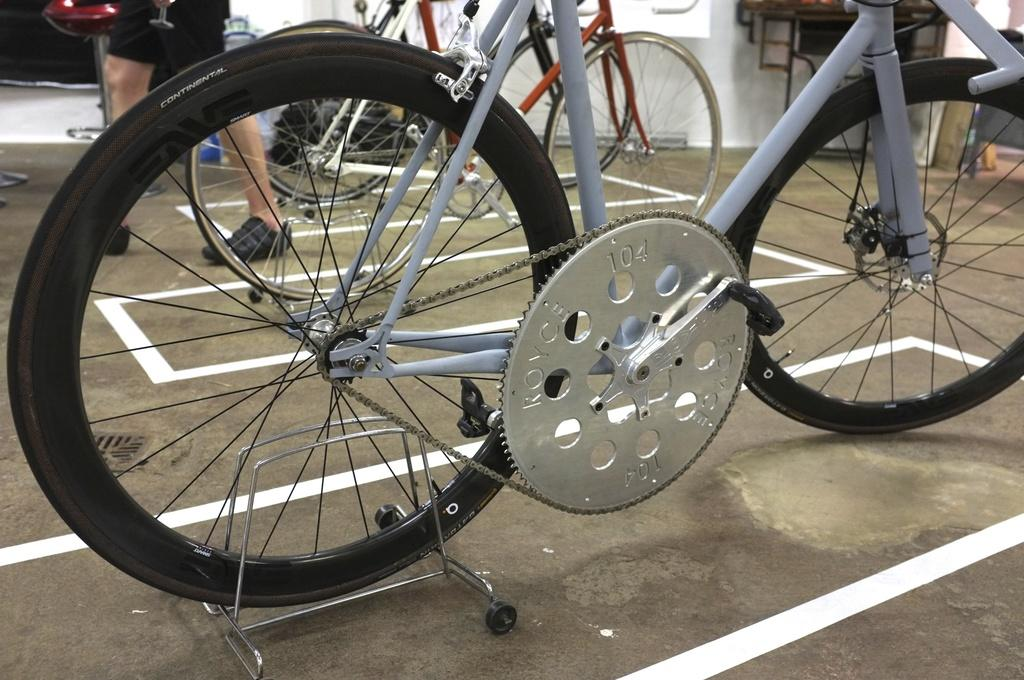What type of vehicles are in the picture? There are bicycles in the picture. Can you describe the person in the picture? There is a person standing in the picture. What other objects can be seen in the picture besides the bicycles and person? There are some other objects in the picture. What type of desk can be seen in the picture? There is no desk present in the picture. Are there any fowl visible in the image? There is no fowl present in the image. 